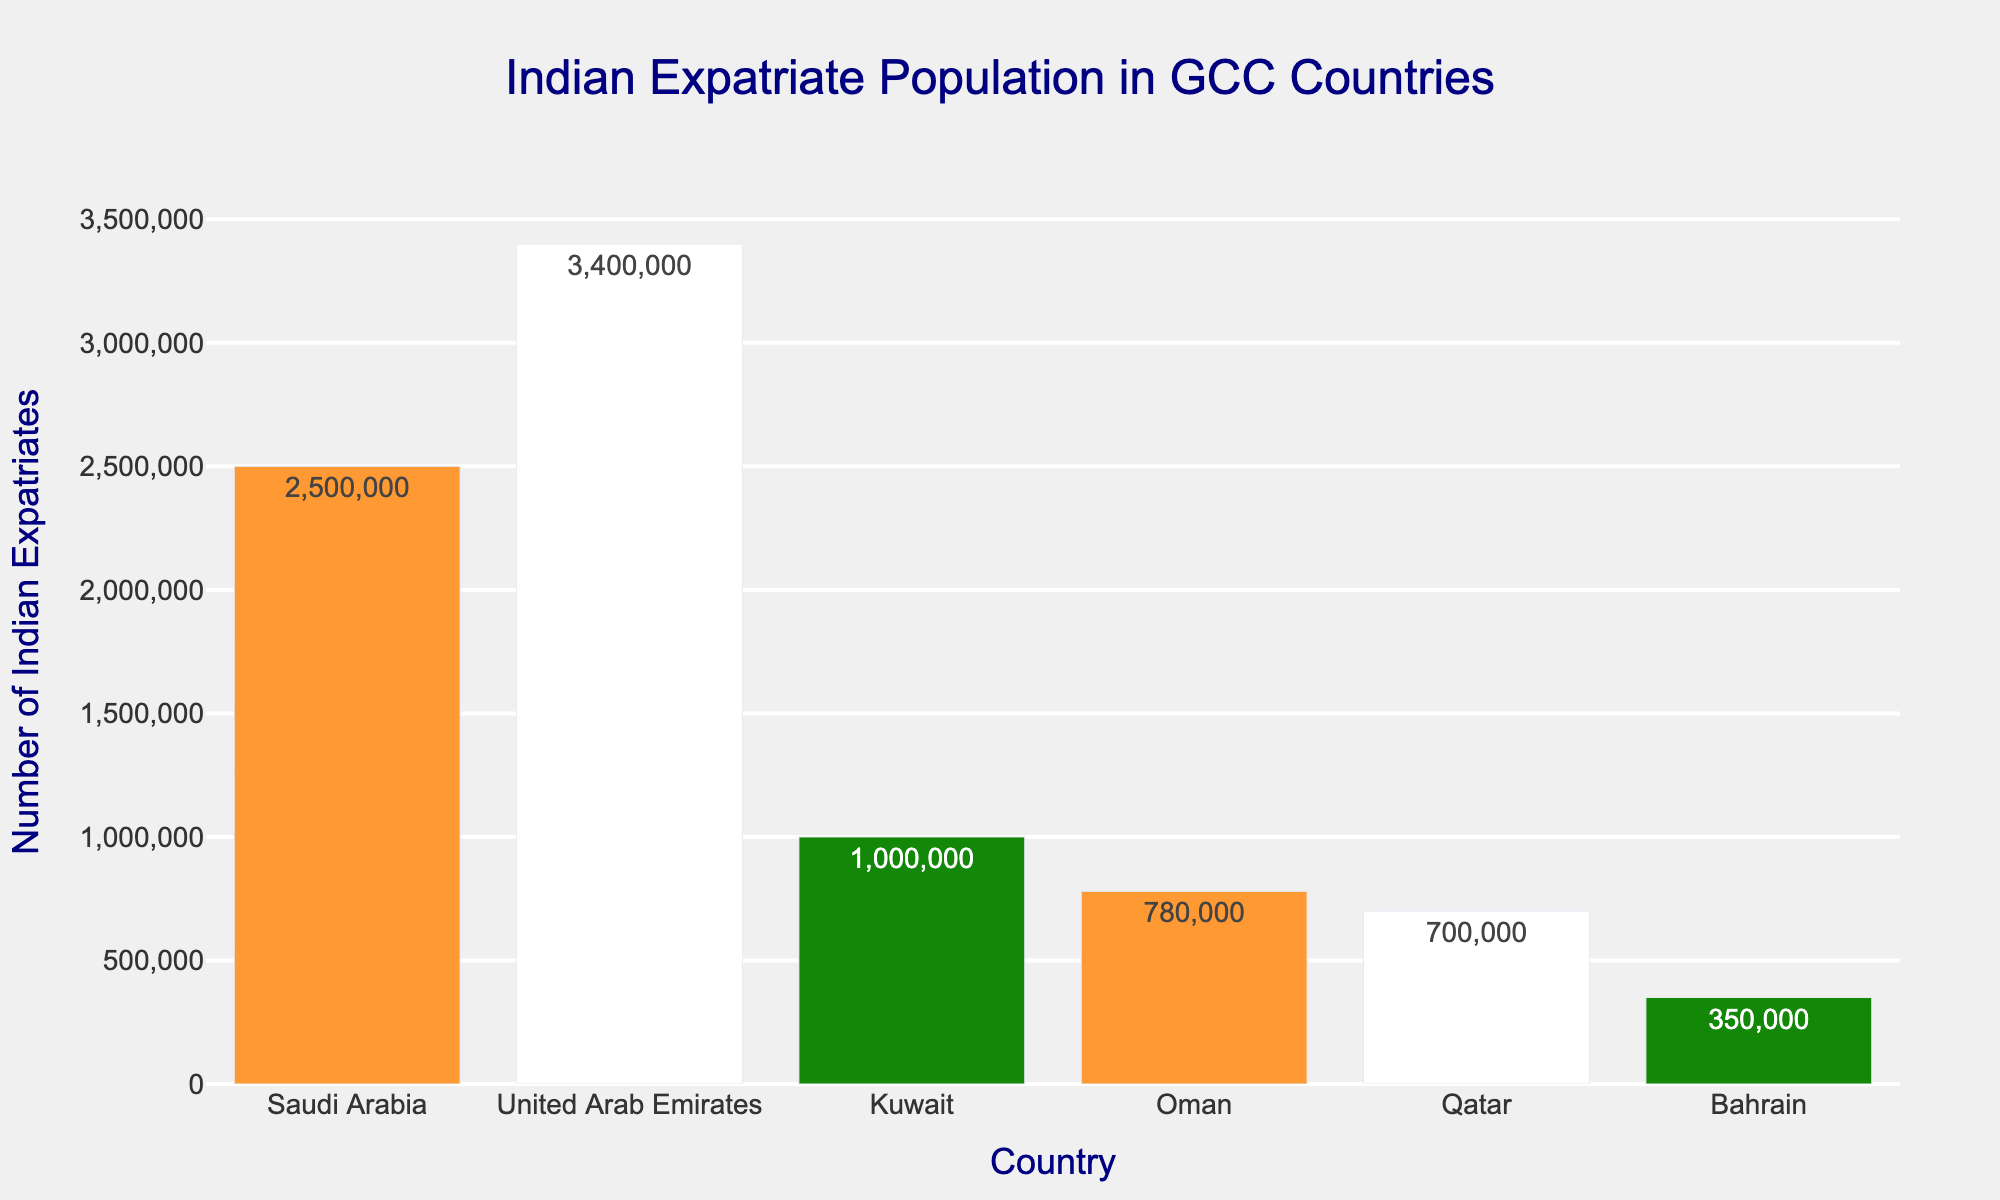Which country has the largest Indian expatriate population? By observing the heights of the bars, it's clear that the bar representing the United Arab Emirates is the tallest.
Answer: United Arab Emirates Which country has the smallest Indian expatriate population? By observing the shortest bar, Bahrain has the smallest Indian expatriate population.
Answer: Bahrain How many more Indian expatriates are there in the United Arab Emirates compared to Oman? The number of Indian expatriates in the United Arab Emirates is 3,400,000, while in Oman it is 780,000. Subtract Oman’s population from the UAE’s population: 3,400,000 - 780,000 = 2,620,000
Answer: 2,620,000 What is the total Indian expatriate population in Saudi Arabia, Kuwait, and Qatar combined? Add the populations of Indian expatriates in Saudi Arabia (2,500,000), Kuwait (1,000,000), and Qatar (700,000): 2,500,000 + 1,000,000 + 700,000 = 4,200,000
Answer: 4,200,000 Which countries have Indian expatriate populations greater than 1 million? The countries with Indian expatriate populations greater than 1 million are those with bars extending past the 1 million mark. These are Saudi Arabia (2,500,000), United Arab Emirates (3,400,000), and Kuwait (1,000,000).
Answer: Saudi Arabia, United Arab Emirates, Kuwait What is the average number of Indian expatriates across all the GCC countries? Sum the Indian expatriate populations of all GCC countries and then divide by the number of countries. (2,500,000 + 3,400,000 + 1,000,000 + 780,000 + 700,000 + 350,000) / 6 = 8,730,000 / 6 = 1,455,000
Answer: 1,455,000 How does the Indian expatriate population in Kuwait compare to that in Qatar? The Indian expatriate population in Kuwait (1,000,000) is greater than that in Qatar (700,000).
Answer: Greater What is the difference in the Indian expatriate population between Saudi Arabia and Bahrain? Subtract the Indian expatriate population in Bahrain (350,000) from that in Saudi Arabia (2,500,000): 2,500,000 - 350,000 = 2,150,000
Answer: 2,150,000 What proportion of total Indian expatriates in the GCC live in the United Arab Emirates? Divide the number of Indian expatriates in the UAE by the total number of Indian expatriates in the GCC. The total is 8,730,000. So, 3,400,000 / 8,730,000 ≈ 0.389 or 38.9%.
Answer: 38.9% Which country has a middle-height bar, and what does that say about its Indian expatriate population compared to other GCC countries? Oman has the middle-height bar, indicating its Indian expatriate population (780,000) is neither the highest nor the lowest among the GCC countries.
Answer: Oman 